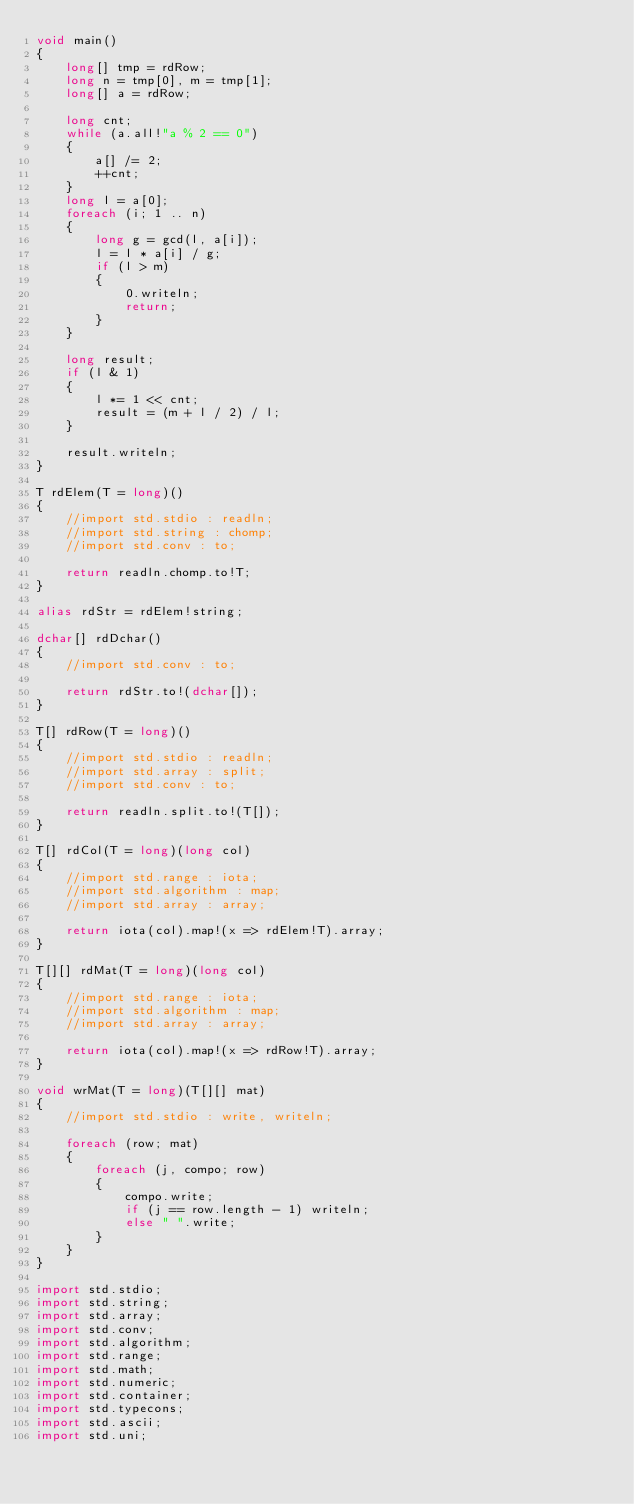<code> <loc_0><loc_0><loc_500><loc_500><_D_>void main()
{
    long[] tmp = rdRow;
    long n = tmp[0], m = tmp[1];
    long[] a = rdRow;

    long cnt;
    while (a.all!"a % 2 == 0")
    {
        a[] /= 2;
        ++cnt;
    }
    long l = a[0];
    foreach (i; 1 .. n)
    {
        long g = gcd(l, a[i]);
        l = l * a[i] / g;
        if (l > m)
        {
            0.writeln;
            return;
        }
    }

    long result;
    if (l & 1)
    {
        l *= 1 << cnt;
        result = (m + l / 2) / l;
    }

    result.writeln;
}

T rdElem(T = long)()
{
    //import std.stdio : readln;
    //import std.string : chomp;
    //import std.conv : to;

    return readln.chomp.to!T;
}

alias rdStr = rdElem!string;

dchar[] rdDchar()
{
    //import std.conv : to;

    return rdStr.to!(dchar[]);
}

T[] rdRow(T = long)()
{
    //import std.stdio : readln;
    //import std.array : split;
    //import std.conv : to;

    return readln.split.to!(T[]);
}

T[] rdCol(T = long)(long col)
{
    //import std.range : iota;
    //import std.algorithm : map;
    //import std.array : array;

    return iota(col).map!(x => rdElem!T).array;
}

T[][] rdMat(T = long)(long col)
{
    //import std.range : iota;
    //import std.algorithm : map;
    //import std.array : array;

    return iota(col).map!(x => rdRow!T).array;
}

void wrMat(T = long)(T[][] mat)
{
    //import std.stdio : write, writeln;

    foreach (row; mat)
    {
        foreach (j, compo; row)
        {
            compo.write;
            if (j == row.length - 1) writeln;
            else " ".write;
        }
    }
}

import std.stdio;
import std.string;
import std.array;
import std.conv;
import std.algorithm;
import std.range;
import std.math;
import std.numeric;
import std.container;
import std.typecons;
import std.ascii;
import std.uni;</code> 